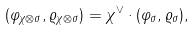<formula> <loc_0><loc_0><loc_500><loc_500>( \varphi _ { \chi \otimes \sigma } , \varrho _ { \chi \otimes \sigma } ) = \chi ^ { \vee } \cdot ( \varphi _ { \sigma } , \varrho _ { \sigma } ) ,</formula> 